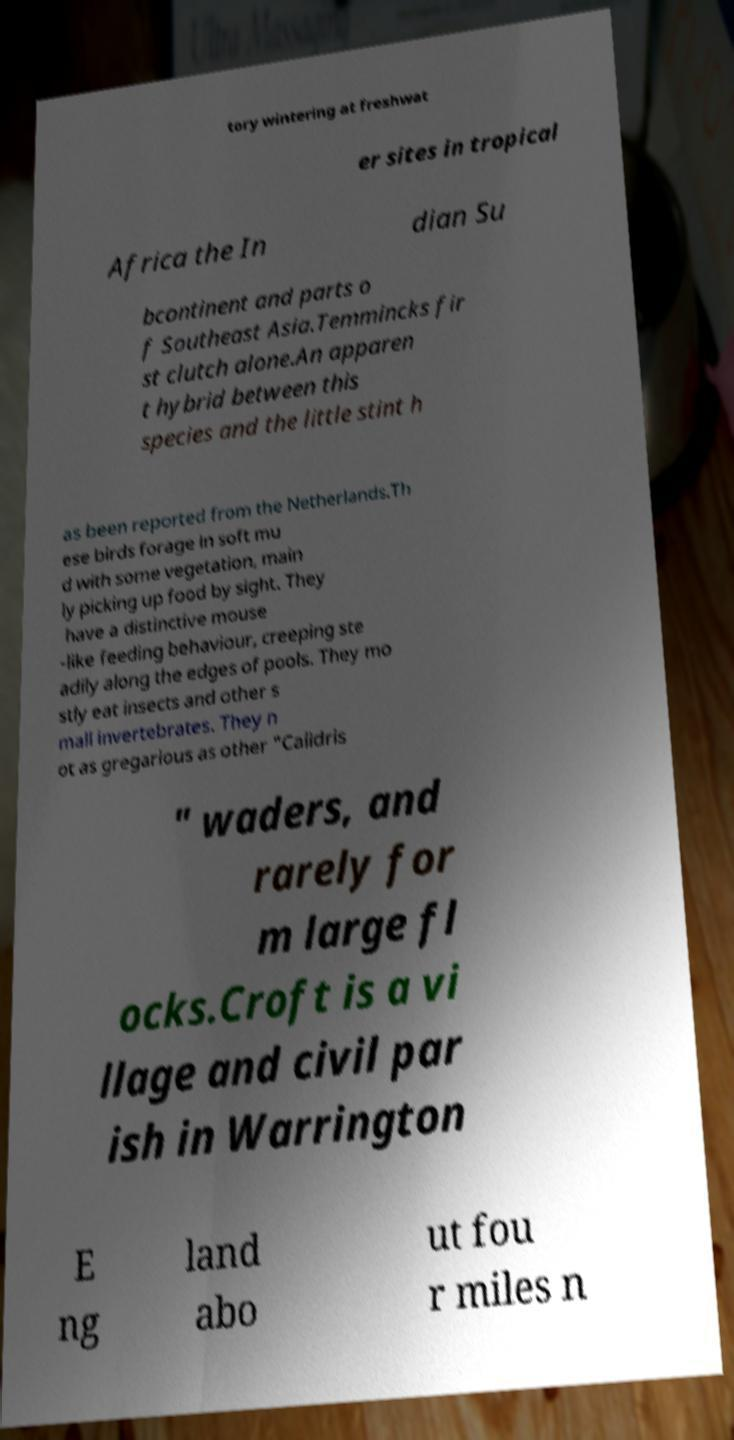Could you assist in decoding the text presented in this image and type it out clearly? tory wintering at freshwat er sites in tropical Africa the In dian Su bcontinent and parts o f Southeast Asia.Temmincks fir st clutch alone.An apparen t hybrid between this species and the little stint h as been reported from the Netherlands.Th ese birds forage in soft mu d with some vegetation, main ly picking up food by sight. They have a distinctive mouse -like feeding behaviour, creeping ste adily along the edges of pools. They mo stly eat insects and other s mall invertebrates. They n ot as gregarious as other "Calidris " waders, and rarely for m large fl ocks.Croft is a vi llage and civil par ish in Warrington E ng land abo ut fou r miles n 